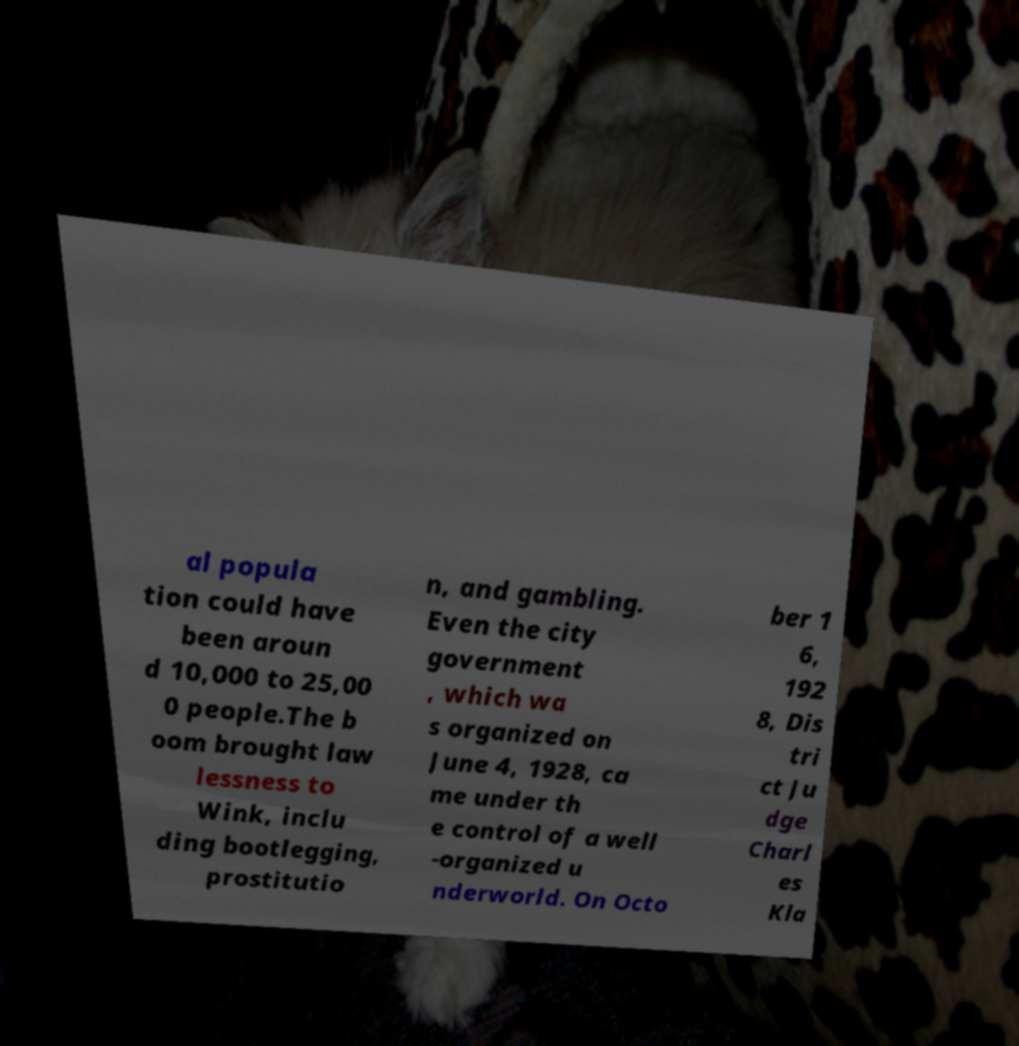Please read and relay the text visible in this image. What does it say? al popula tion could have been aroun d 10,000 to 25,00 0 people.The b oom brought law lessness to Wink, inclu ding bootlegging, prostitutio n, and gambling. Even the city government , which wa s organized on June 4, 1928, ca me under th e control of a well -organized u nderworld. On Octo ber 1 6, 192 8, Dis tri ct Ju dge Charl es Kla 